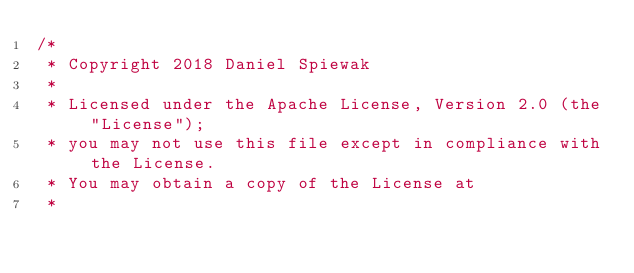<code> <loc_0><loc_0><loc_500><loc_500><_Scala_>/*
 * Copyright 2018 Daniel Spiewak
 *
 * Licensed under the Apache License, Version 2.0 (the "License");
 * you may not use this file except in compliance with the License.
 * You may obtain a copy of the License at
 *</code> 